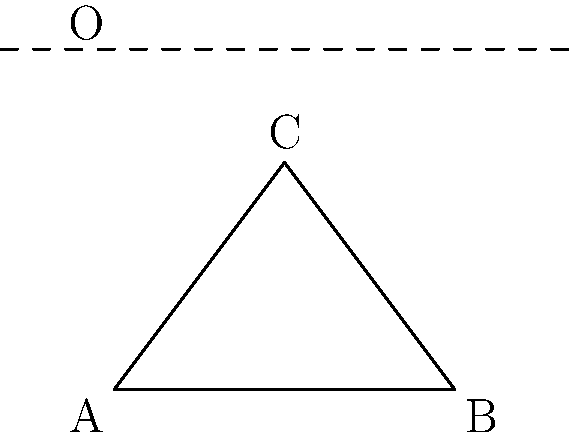Triangle ABC is reflected across the line $y=3$ to create triangle A'B'C'. Given that the coordinates of point C are $(1.5, 2)$, what are the coordinates of point C' after the reflection? To find the coordinates of C' after reflecting point C across the line $y=3$, we can follow these steps:

1) The general formula for reflecting a point $(x, y)$ across the line $y=k$ is $(x, 2k-y)$.

2) In this case, $k=3$ (the line of reflection is $y=3$), and the original point C has coordinates $(1.5, 2)$.

3) Let's substitute these values into the formula:
   $x$ remains the same: $1.5$
   $y$ becomes: $2k - y = 2(3) - 2 = 6 - 2 = 4$

4) Therefore, the coordinates of C' are $(1.5, 4)$.

This method works because the line of reflection acts as a mirror, and the distance of a point from the line is preserved after reflection, but on the opposite side of the line.
Answer: $(1.5, 4)$ 